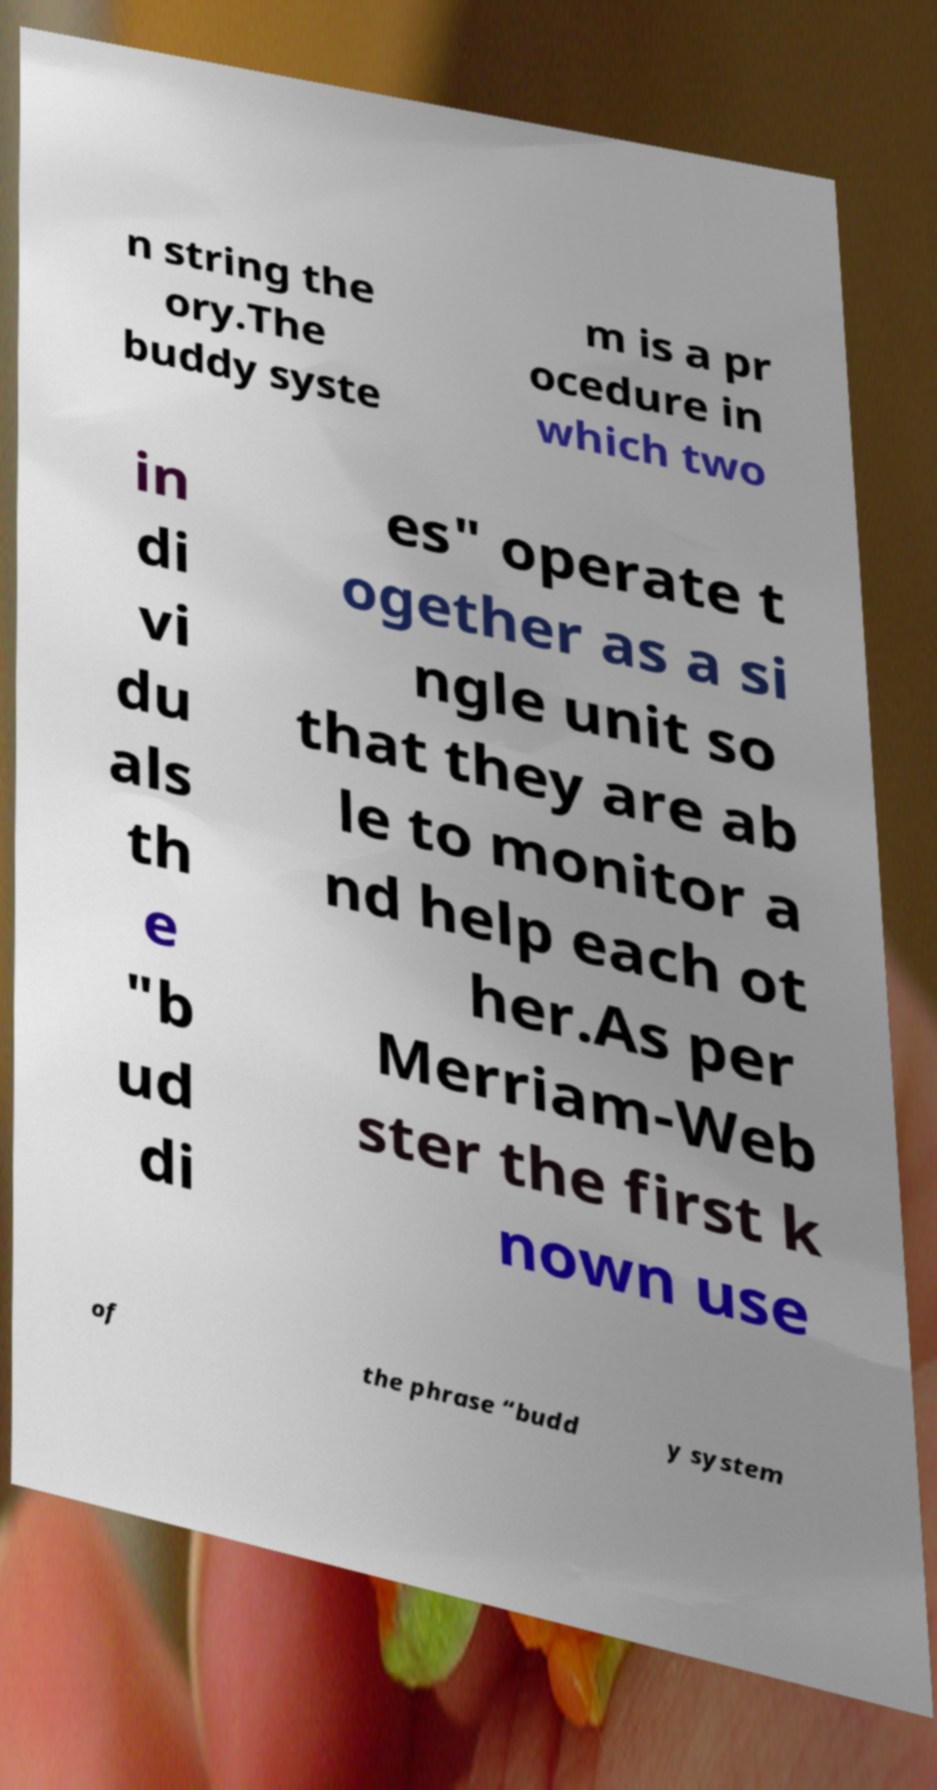Can you accurately transcribe the text from the provided image for me? n string the ory.The buddy syste m is a pr ocedure in which two in di vi du als th e "b ud di es" operate t ogether as a si ngle unit so that they are ab le to monitor a nd help each ot her.As per Merriam-Web ster the first k nown use of the phrase “budd y system 